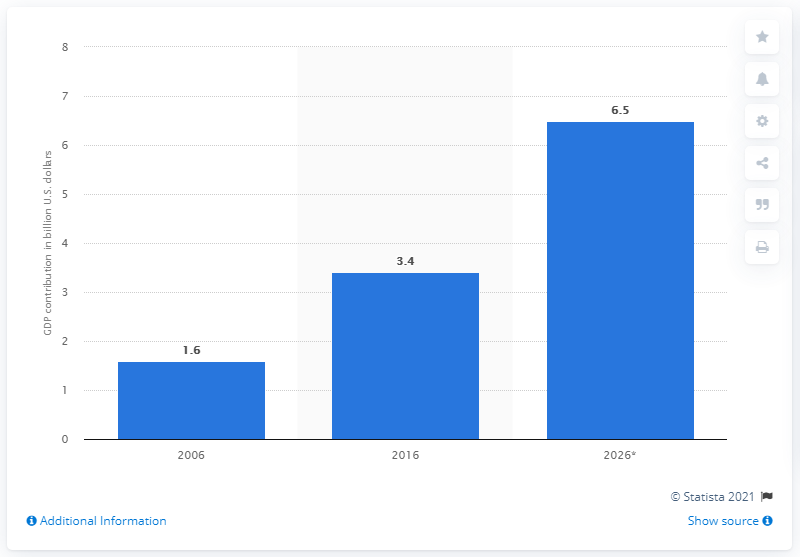Outline some significant characteristics in this image. The direct tourism contribution of Riyadh to the GDP of Saudi Arabia is projected to be 6.5% by 2026. 